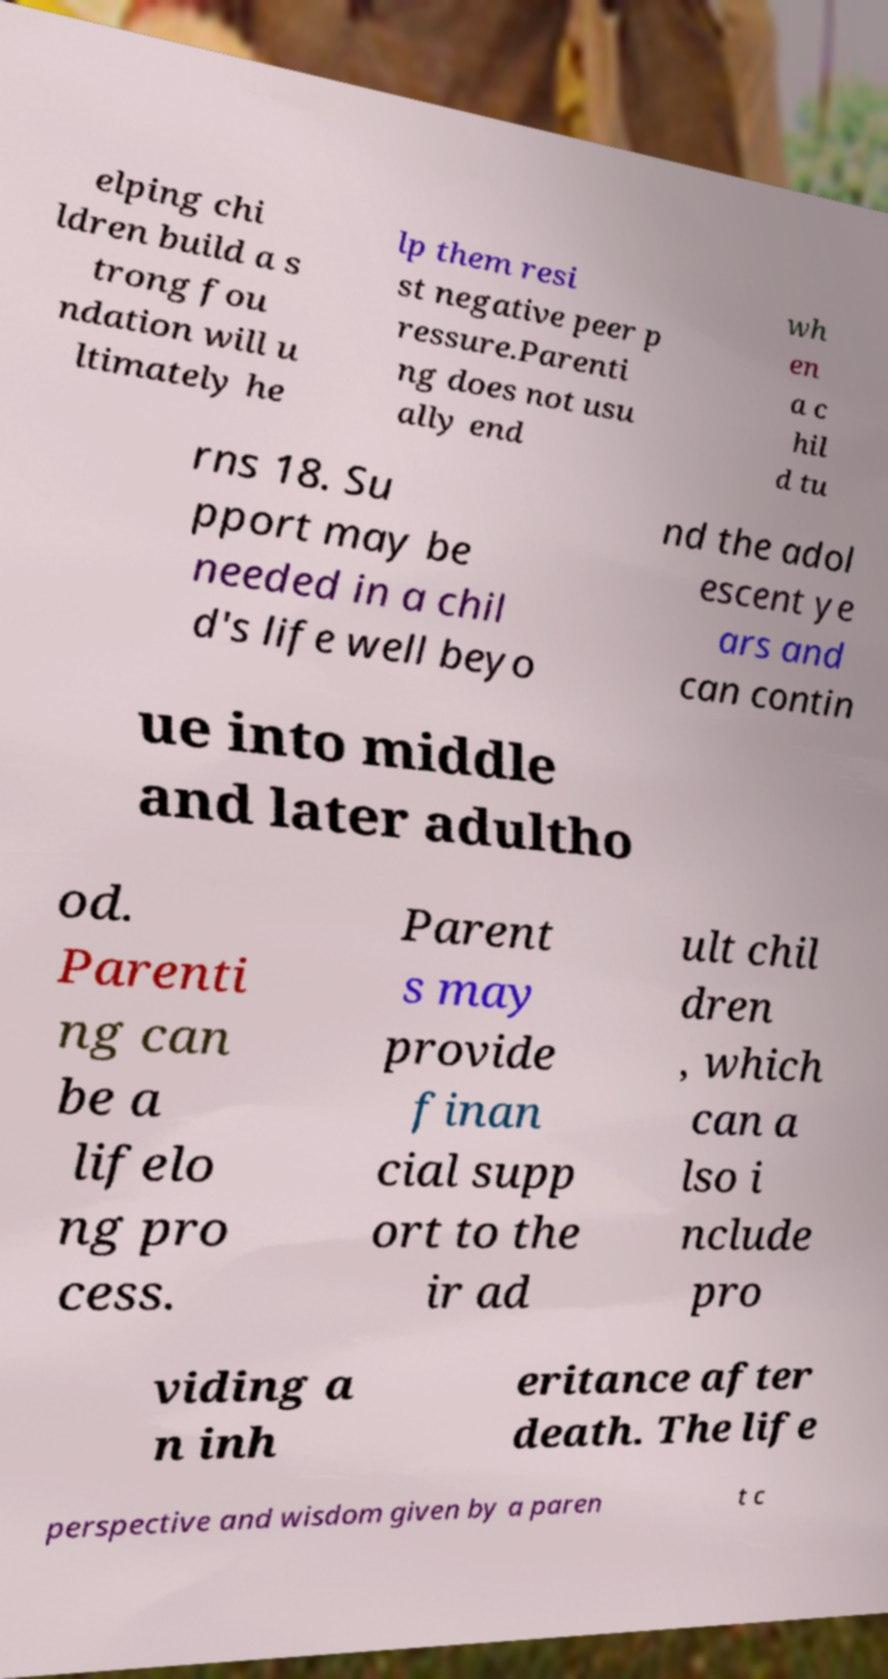Can you read and provide the text displayed in the image?This photo seems to have some interesting text. Can you extract and type it out for me? elping chi ldren build a s trong fou ndation will u ltimately he lp them resi st negative peer p ressure.Parenti ng does not usu ally end wh en a c hil d tu rns 18. Su pport may be needed in a chil d's life well beyo nd the adol escent ye ars and can contin ue into middle and later adultho od. Parenti ng can be a lifelo ng pro cess. Parent s may provide finan cial supp ort to the ir ad ult chil dren , which can a lso i nclude pro viding a n inh eritance after death. The life perspective and wisdom given by a paren t c 